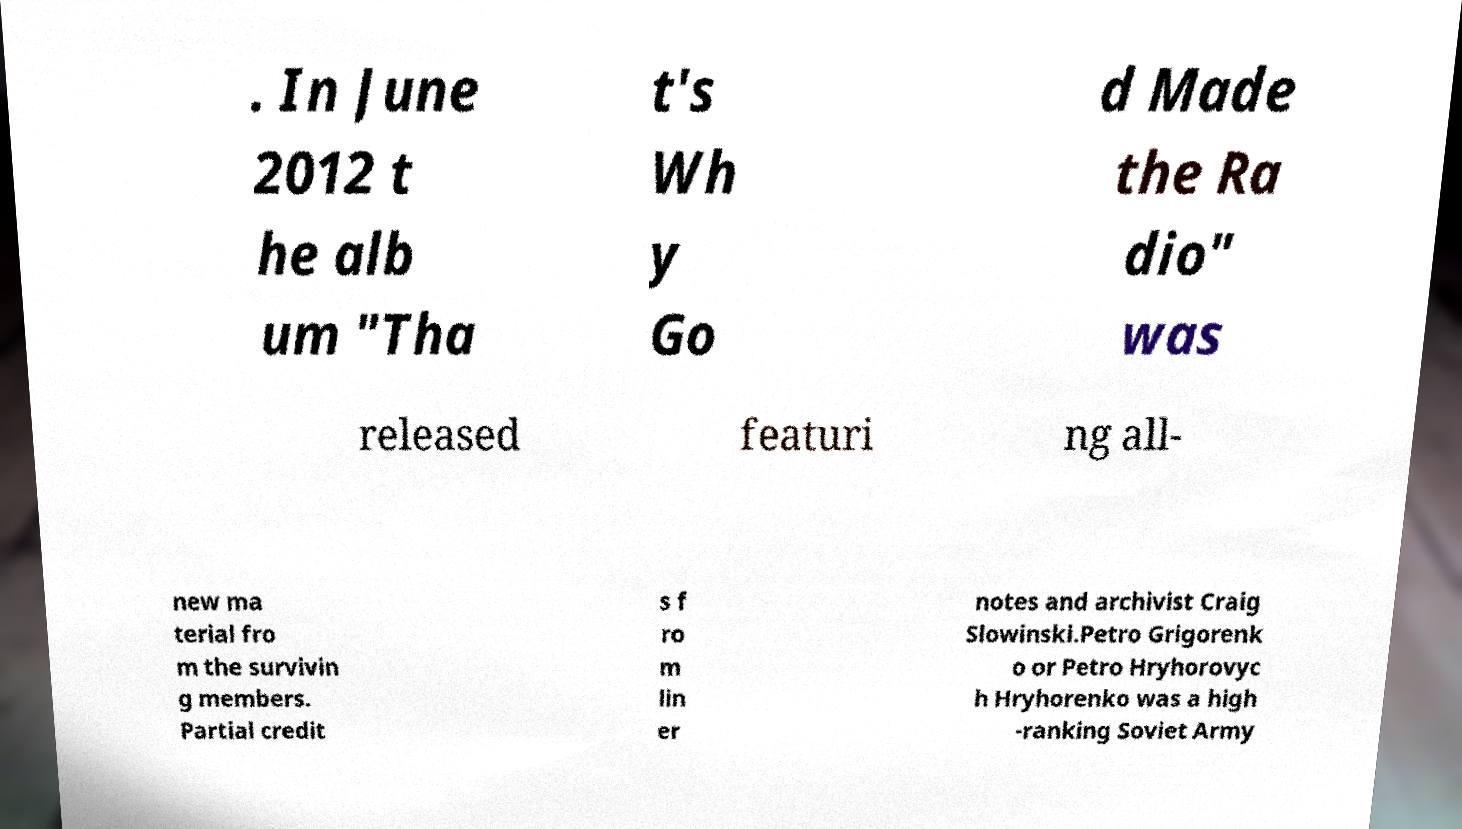Please identify and transcribe the text found in this image. . In June 2012 t he alb um "Tha t's Wh y Go d Made the Ra dio" was released featuri ng all- new ma terial fro m the survivin g members. Partial credit s f ro m lin er notes and archivist Craig Slowinski.Petro Grigorenk o or Petro Hryhorovyc h Hryhorenko was a high -ranking Soviet Army 